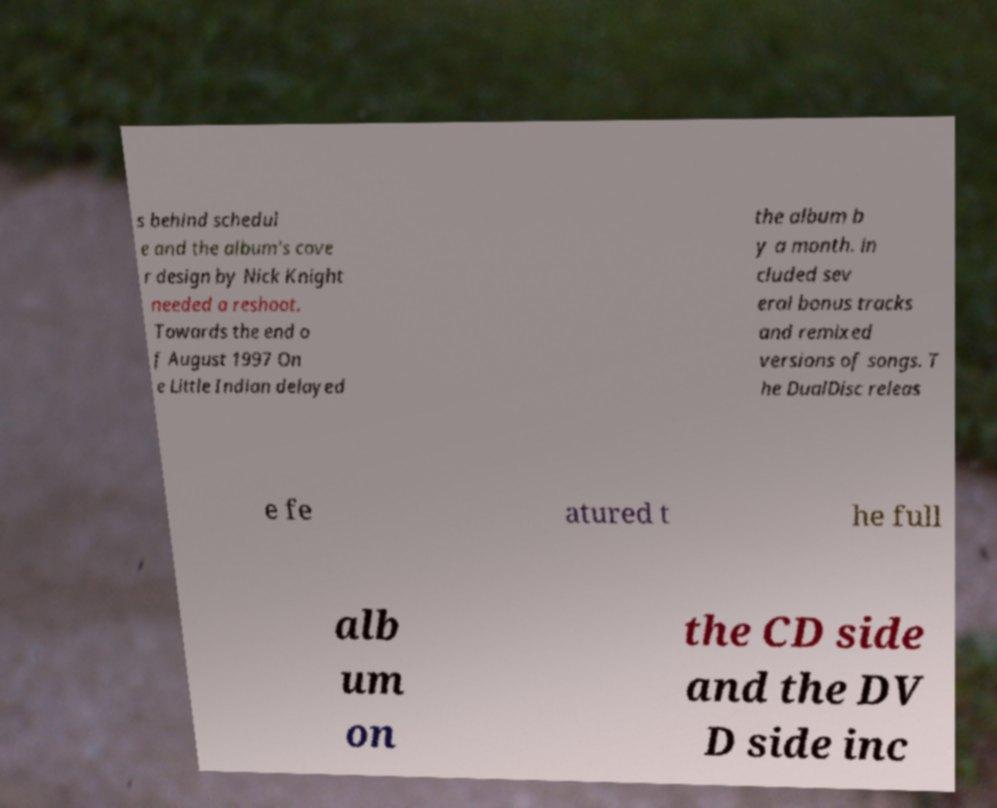Could you extract and type out the text from this image? s behind schedul e and the album's cove r design by Nick Knight needed a reshoot. Towards the end o f August 1997 On e Little Indian delayed the album b y a month. in cluded sev eral bonus tracks and remixed versions of songs. T he DualDisc releas e fe atured t he full alb um on the CD side and the DV D side inc 